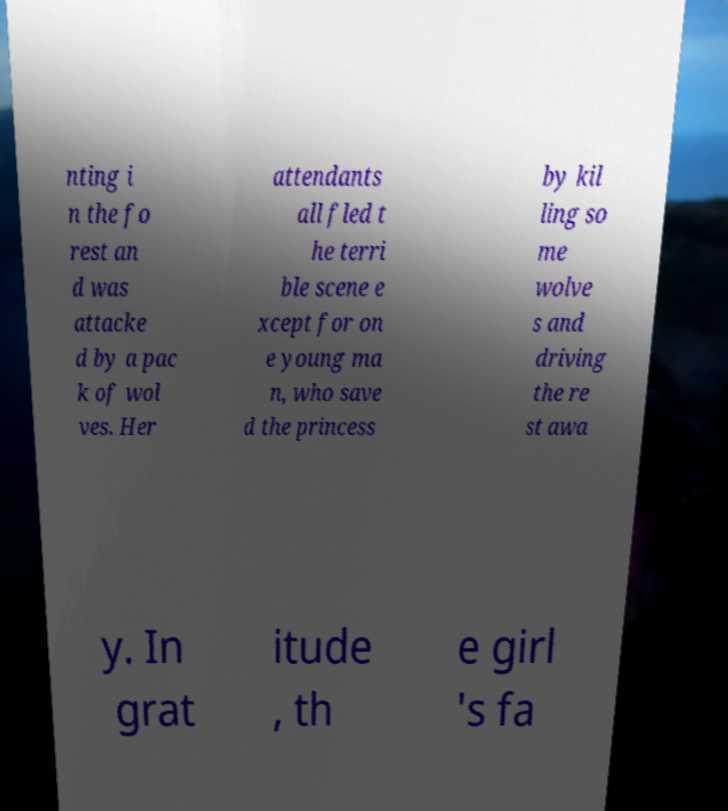For documentation purposes, I need the text within this image transcribed. Could you provide that? nting i n the fo rest an d was attacke d by a pac k of wol ves. Her attendants all fled t he terri ble scene e xcept for on e young ma n, who save d the princess by kil ling so me wolve s and driving the re st awa y. In grat itude , th e girl 's fa 